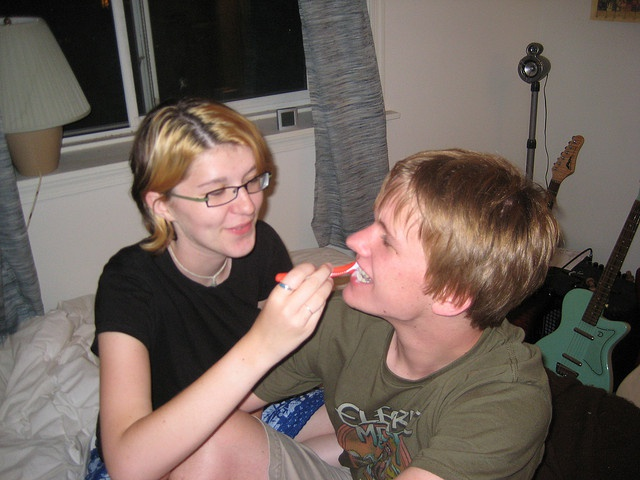Describe the objects in this image and their specific colors. I can see people in black, gray, lightpink, and maroon tones, people in black, lightpink, gray, and pink tones, bed in black, darkgray, and gray tones, and toothbrush in black, salmon, lightpink, white, and gray tones in this image. 